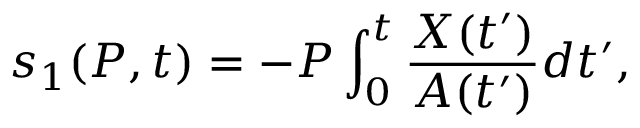<formula> <loc_0><loc_0><loc_500><loc_500>s _ { 1 } ( P , t ) = - P \int _ { 0 } ^ { t } \frac { X ( t ^ { \prime } ) } { A ( t ^ { \prime } ) } d t ^ { \prime } ,</formula> 